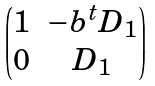<formula> <loc_0><loc_0><loc_500><loc_500>\begin{pmatrix} 1 & - b ^ { t } D _ { 1 } \\ 0 & D _ { 1 } \end{pmatrix}</formula> 